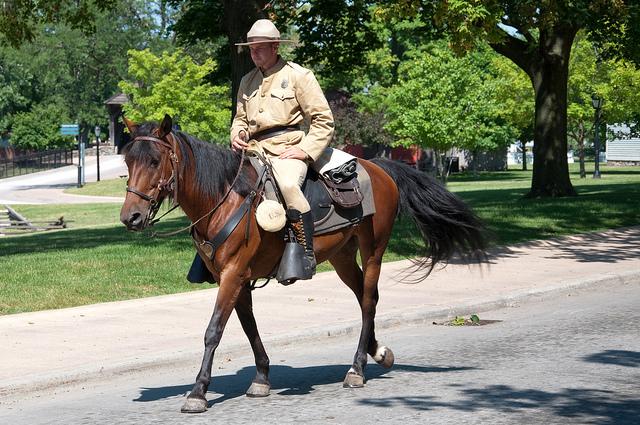Who is walking the horse?
Short answer required. Man. What color is the man's jacket?
Write a very short answer. Tan. What color is the horse?
Give a very brief answer. Brown. Does the pavement hurt the horses feet?
Quick response, please. No. 